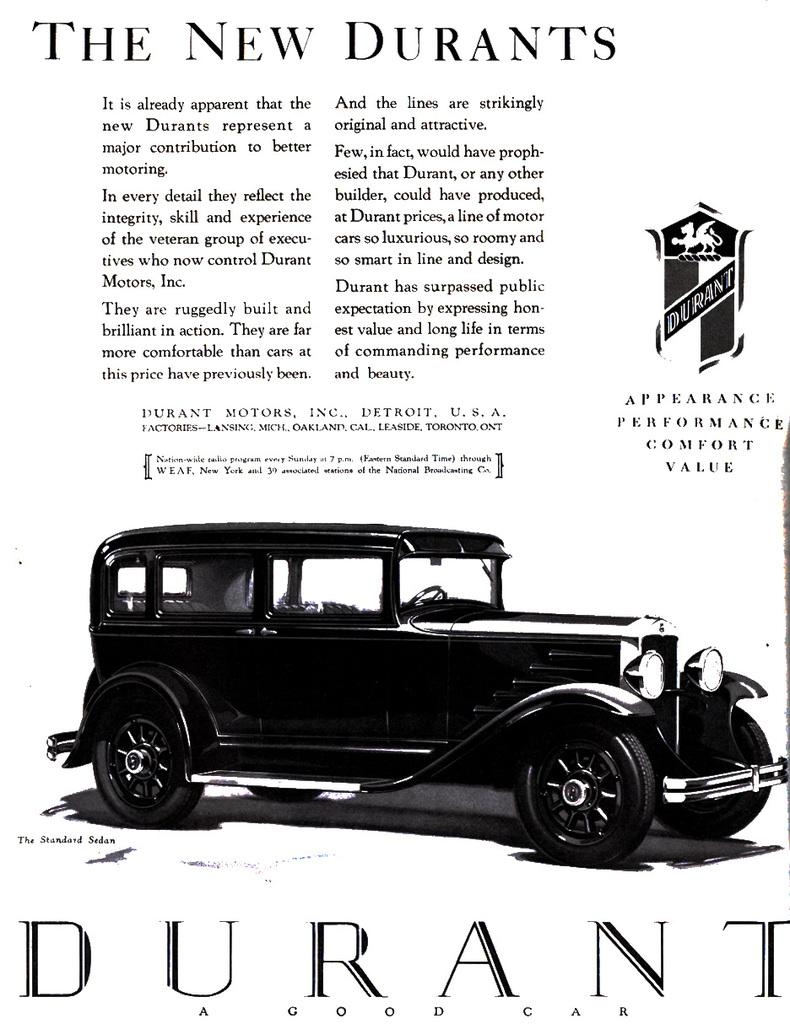What is the color scheme of the poster in the image? The poster is black and white. What is depicted on the poster? There is a car on the poster. What else is featured on the poster besides the image? There is text written on the poster. What type of religious symbol can be seen on the poster? There is no religious symbol present on the poster; it features a car and text. How does the harmony of the poster contribute to the overall design? The poster does not depict harmony as a subject or theme; it features a car and text in a black and white color scheme. 